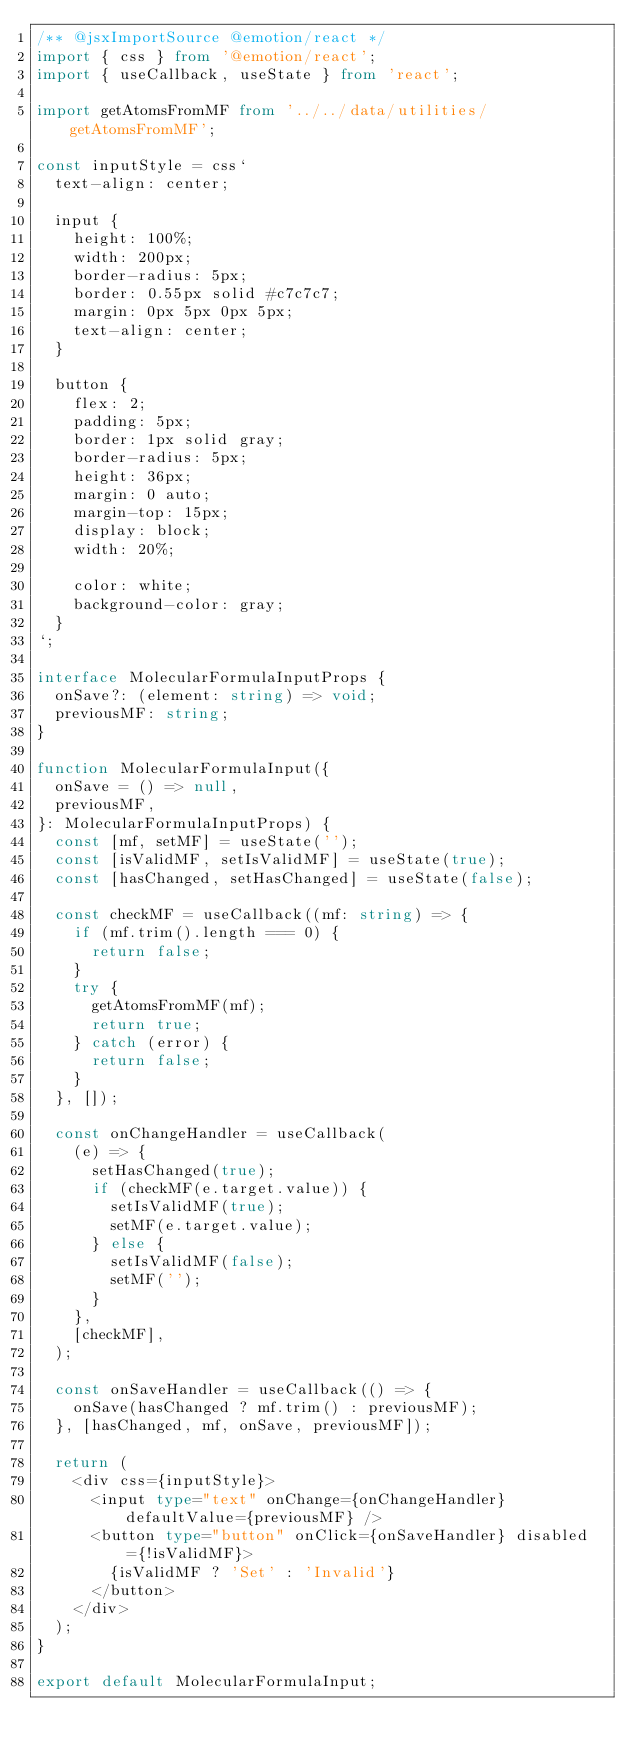<code> <loc_0><loc_0><loc_500><loc_500><_TypeScript_>/** @jsxImportSource @emotion/react */
import { css } from '@emotion/react';
import { useCallback, useState } from 'react';

import getAtomsFromMF from '../../data/utilities/getAtomsFromMF';

const inputStyle = css`
  text-align: center;

  input {
    height: 100%;
    width: 200px;
    border-radius: 5px;
    border: 0.55px solid #c7c7c7;
    margin: 0px 5px 0px 5px;
    text-align: center;
  }

  button {
    flex: 2;
    padding: 5px;
    border: 1px solid gray;
    border-radius: 5px;
    height: 36px;
    margin: 0 auto;
    margin-top: 15px;
    display: block;
    width: 20%;

    color: white;
    background-color: gray;
  }
`;

interface MolecularFormulaInputProps {
  onSave?: (element: string) => void;
  previousMF: string;
}

function MolecularFormulaInput({
  onSave = () => null,
  previousMF,
}: MolecularFormulaInputProps) {
  const [mf, setMF] = useState('');
  const [isValidMF, setIsValidMF] = useState(true);
  const [hasChanged, setHasChanged] = useState(false);

  const checkMF = useCallback((mf: string) => {
    if (mf.trim().length === 0) {
      return false;
    }
    try {
      getAtomsFromMF(mf);
      return true;
    } catch (error) {
      return false;
    }
  }, []);

  const onChangeHandler = useCallback(
    (e) => {
      setHasChanged(true);
      if (checkMF(e.target.value)) {
        setIsValidMF(true);
        setMF(e.target.value);
      } else {
        setIsValidMF(false);
        setMF('');
      }
    },
    [checkMF],
  );

  const onSaveHandler = useCallback(() => {
    onSave(hasChanged ? mf.trim() : previousMF);
  }, [hasChanged, mf, onSave, previousMF]);

  return (
    <div css={inputStyle}>
      <input type="text" onChange={onChangeHandler} defaultValue={previousMF} />
      <button type="button" onClick={onSaveHandler} disabled={!isValidMF}>
        {isValidMF ? 'Set' : 'Invalid'}
      </button>
    </div>
  );
}

export default MolecularFormulaInput;
</code> 